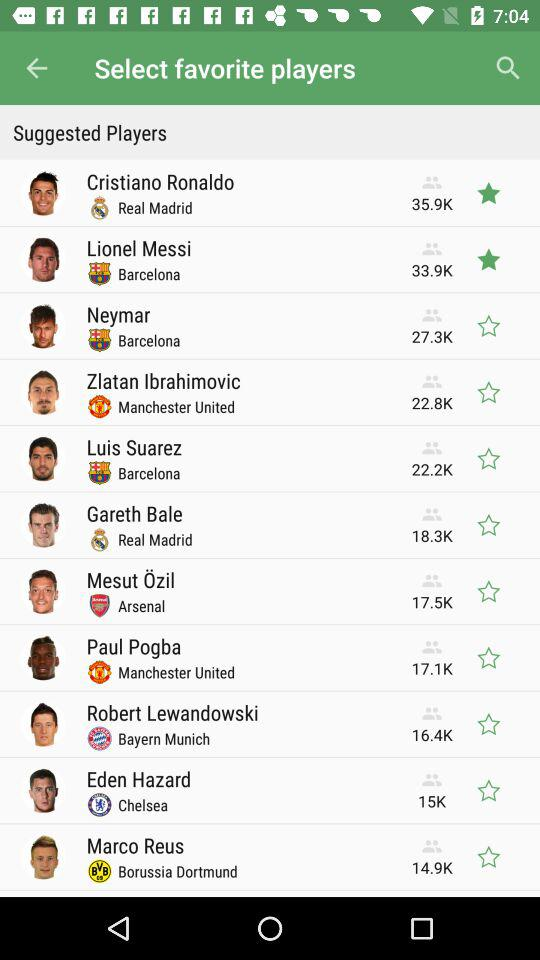Which favorite players are selected?
When the provided information is insufficient, respond with <no answer>. <no answer> 